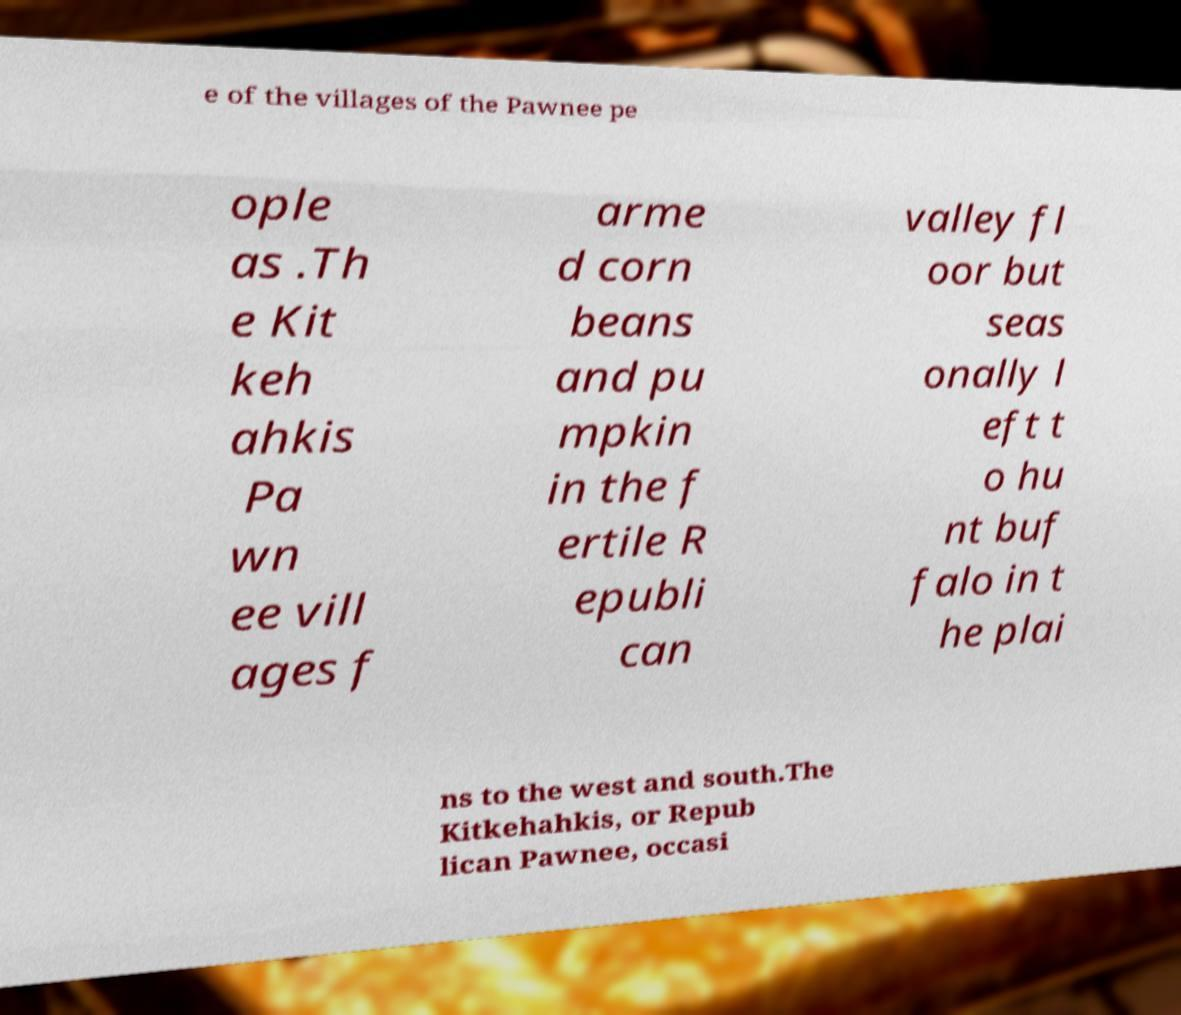There's text embedded in this image that I need extracted. Can you transcribe it verbatim? e of the villages of the Pawnee pe ople as .Th e Kit keh ahkis Pa wn ee vill ages f arme d corn beans and pu mpkin in the f ertile R epubli can valley fl oor but seas onally l eft t o hu nt buf falo in t he plai ns to the west and south.The Kitkehahkis, or Repub lican Pawnee, occasi 